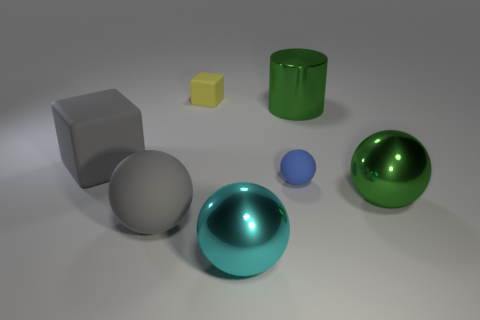Add 2 large blue metal cylinders. How many objects exist? 9 Subtract all purple blocks. Subtract all yellow balls. How many blocks are left? 2 Subtract all blocks. How many objects are left? 5 Add 1 blue things. How many blue things are left? 2 Add 2 tiny blue balls. How many tiny blue balls exist? 3 Subtract 1 green spheres. How many objects are left? 6 Subtract all small cyan metallic blocks. Subtract all big green metal cylinders. How many objects are left? 6 